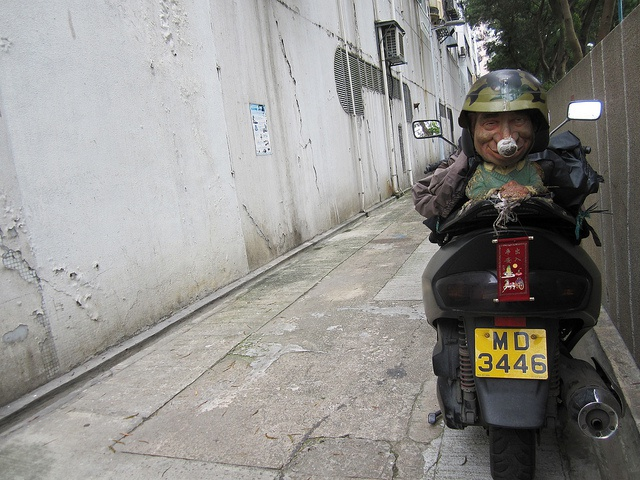Describe the objects in this image and their specific colors. I can see motorcycle in lightgray, black, gray, maroon, and gold tones and people in lightgray, black, gray, and maroon tones in this image. 